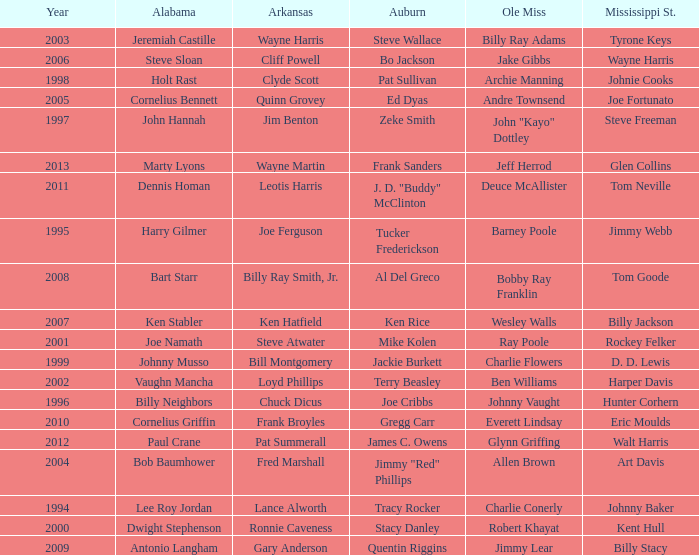Who is the Arkansas player associated with Ken Stabler? Ken Hatfield. 